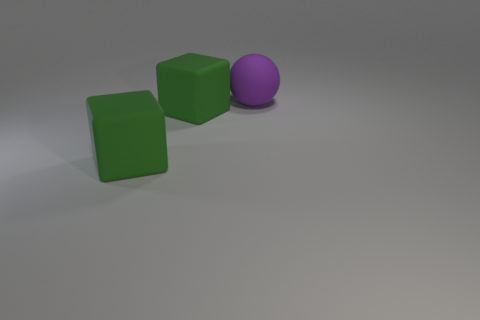What number of other balls are made of the same material as the big sphere?
Give a very brief answer. 0. What number of cylinders are either purple objects or large green shiny things?
Offer a terse response. 0. Is the number of green objects to the right of the purple thing less than the number of things?
Provide a succinct answer. Yes. Are there any big rubber objects in front of the matte ball?
Your answer should be very brief. Yes. What number of things are either large objects that are on the left side of the big purple sphere or brown matte cubes?
Your response must be concise. 2. Are there any other objects that have the same size as the purple rubber thing?
Your response must be concise. Yes. How many other things are there of the same material as the sphere?
Your answer should be compact. 2. Is there any other thing that is the same shape as the big purple rubber object?
Provide a short and direct response. No. Is the number of big green cubes less than the number of tiny yellow cylinders?
Your answer should be compact. No. How many objects are either large green rubber objects to the left of the big matte sphere or large things in front of the rubber ball?
Make the answer very short. 2. 